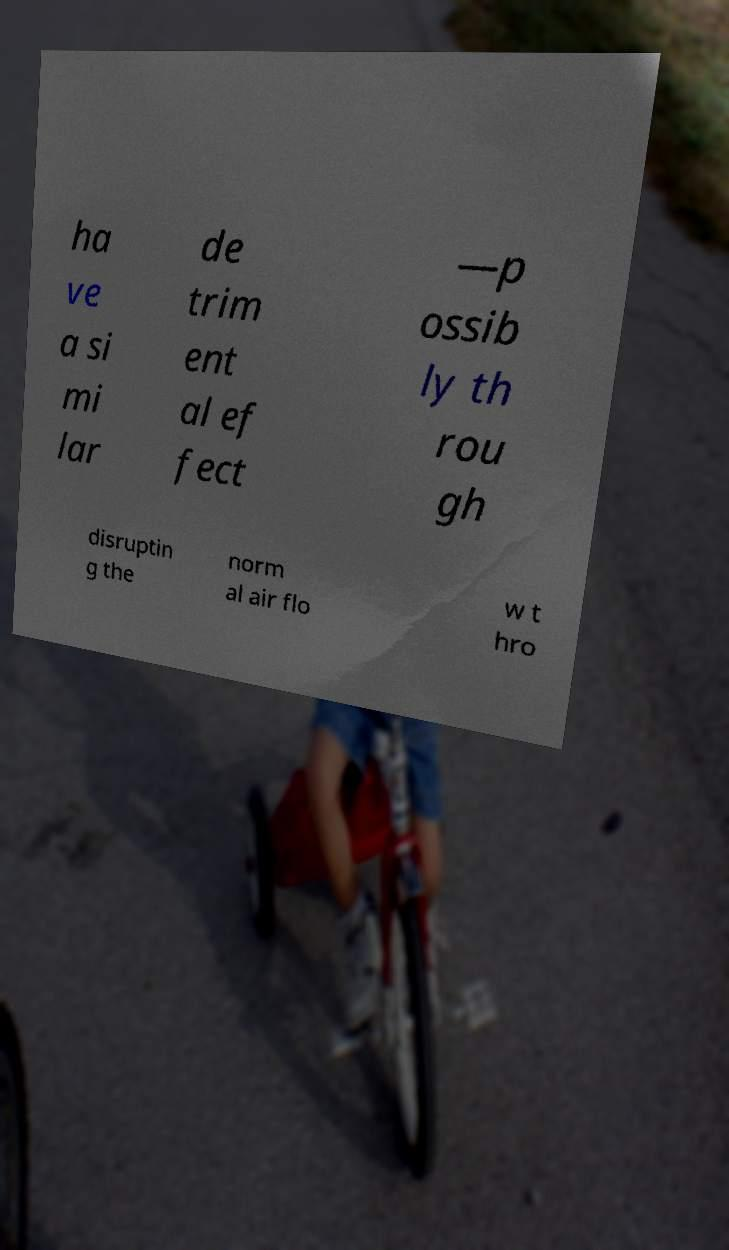Please identify and transcribe the text found in this image. ha ve a si mi lar de trim ent al ef fect —p ossib ly th rou gh disruptin g the norm al air flo w t hro 